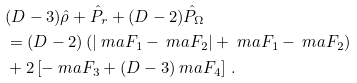<formula> <loc_0><loc_0><loc_500><loc_500>& ( D - 3 ) \hat { \rho } + \hat { P } _ { r } + ( D - 2 ) \hat { P } _ { \Omega } \\ & = ( D - 2 ) \left ( | \ m a F _ { 1 } - \ m a F _ { 2 } | + \ m a F _ { 1 } - \ m a F _ { 2 } \right ) \\ & + 2 \left [ - \ m a F _ { 3 } + ( D - 3 ) \ m a F _ { 4 } \right ] \, .</formula> 